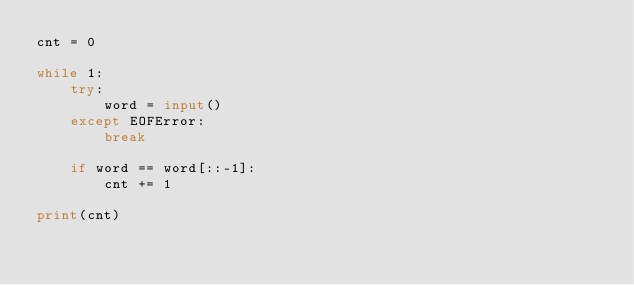<code> <loc_0><loc_0><loc_500><loc_500><_Python_>cnt = 0

while 1:
    try:
        word = input()
    except EOFError:
        break

    if word == word[::-1]:
        cnt += 1

print(cnt)

</code> 